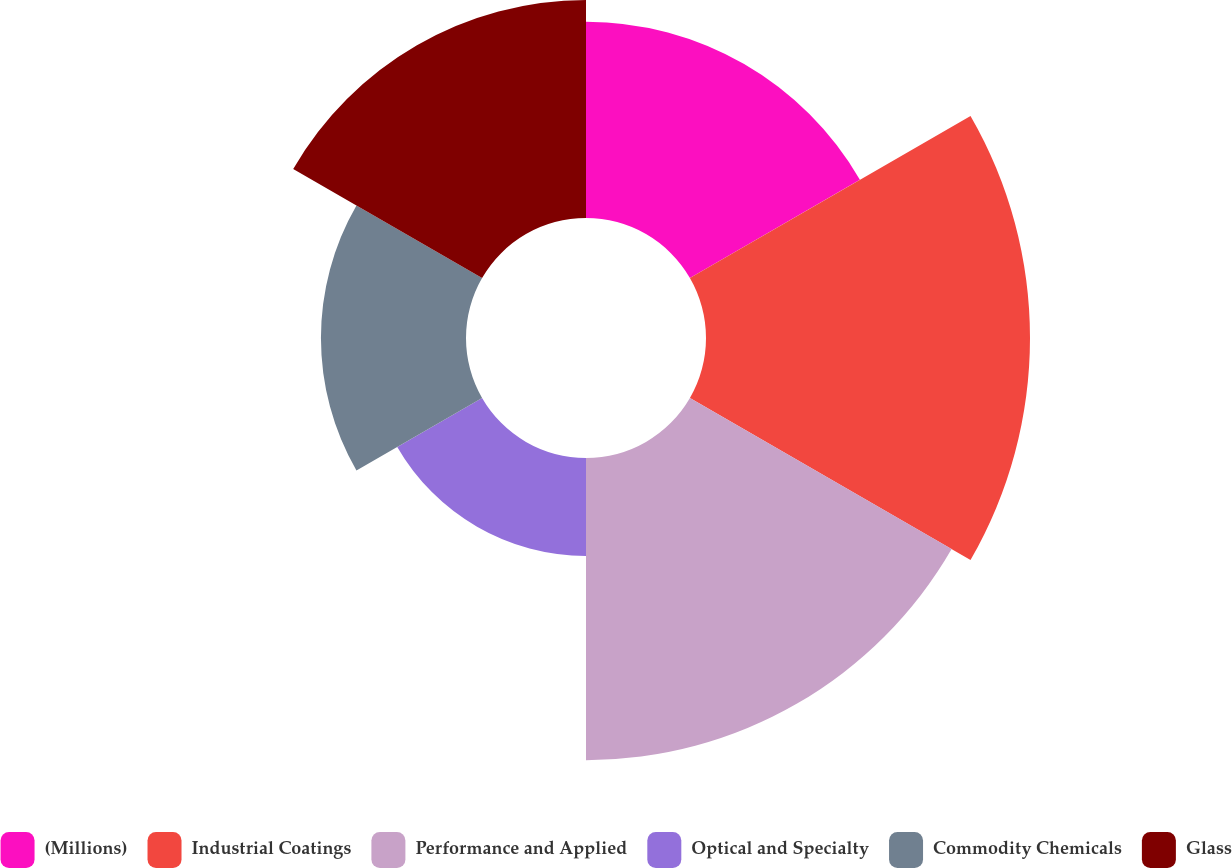Convert chart to OTSL. <chart><loc_0><loc_0><loc_500><loc_500><pie_chart><fcel>(Millions)<fcel>Industrial Coatings<fcel>Performance and Applied<fcel>Optical and Specialty<fcel>Commodity Chemicals<fcel>Glass<nl><fcel>15.29%<fcel>25.24%<fcel>23.54%<fcel>7.63%<fcel>11.3%<fcel>16.99%<nl></chart> 